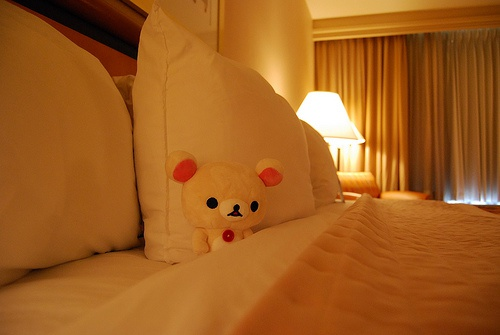Describe the objects in this image and their specific colors. I can see bed in red, maroon, and orange tones, teddy bear in maroon, red, orange, brown, and black tones, and chair in maroon, red, and orange tones in this image. 